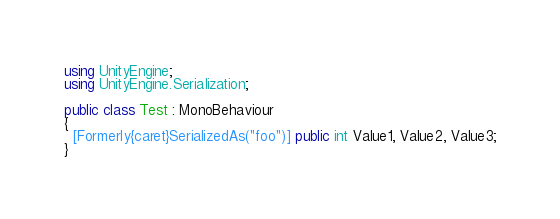Convert code to text. <code><loc_0><loc_0><loc_500><loc_500><_C#_>using UnityEngine;
using UnityEngine.Serialization;

public class Test : MonoBehaviour
{
  [Formerly{caret}SerializedAs("foo")] public int Value1, Value2, Value3;
}
</code> 